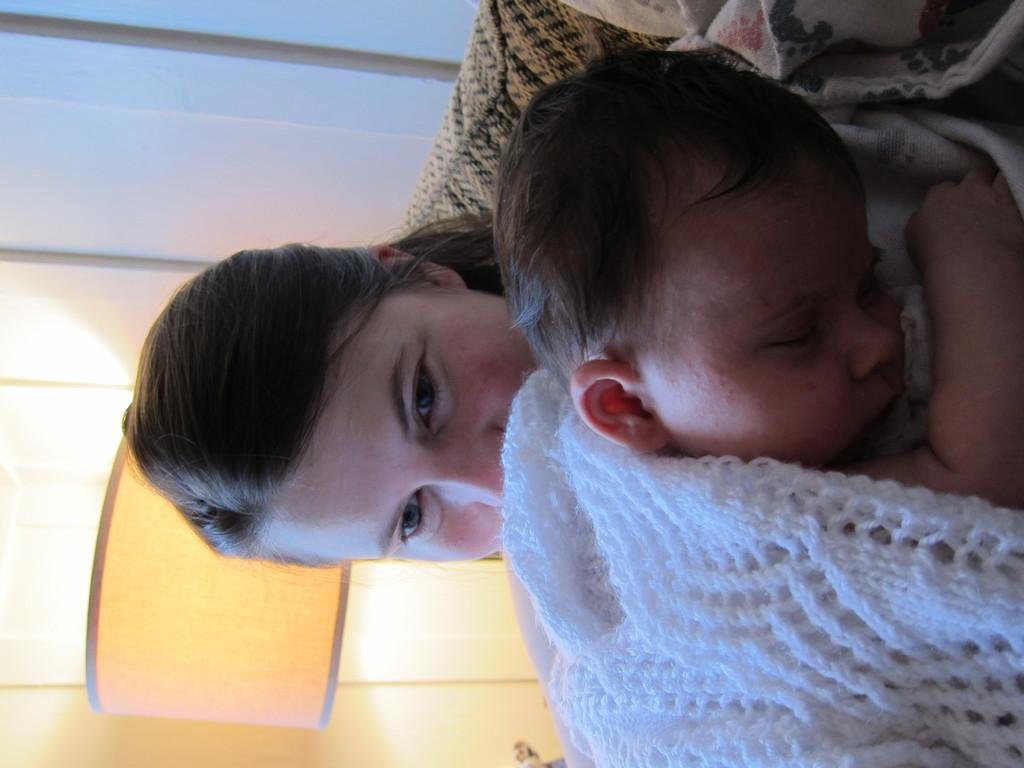Who is the main subject in the image? There is a lady in the image. What is the lady doing in the image? The lady is holding a baby. What can be seen in the background of the image? There is a lamp in the background of the image. What type of metal is the baby afraid of in the image? There is no indication of fear or metal in the image; the lady is simply holding a baby, and there is a lamp in the background. 